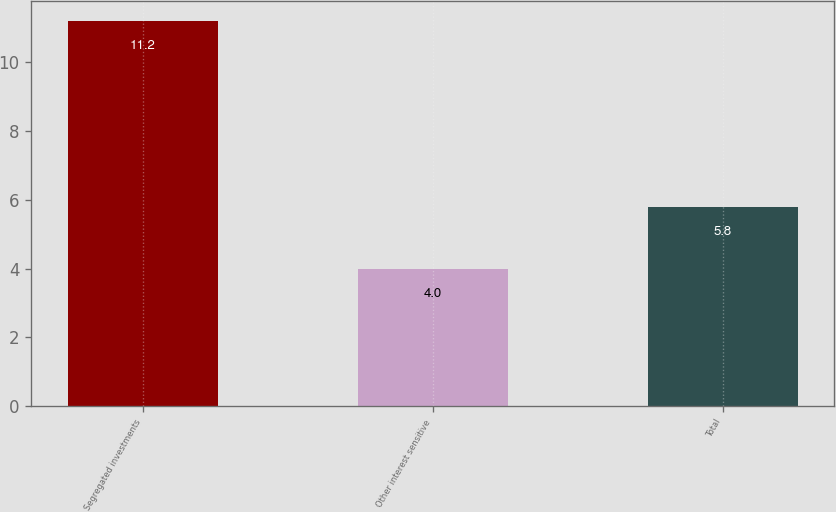Convert chart. <chart><loc_0><loc_0><loc_500><loc_500><bar_chart><fcel>Segregated investments<fcel>Other interest sensitive<fcel>Total<nl><fcel>11.2<fcel>4<fcel>5.8<nl></chart> 